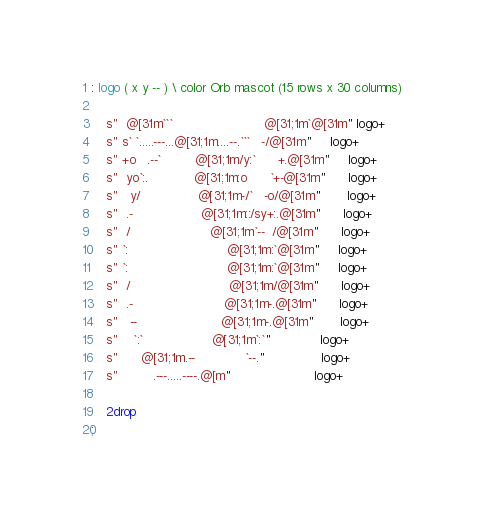Convert code to text. <code><loc_0><loc_0><loc_500><loc_500><_Forth_>
: logo ( x y -- ) \ color Orb mascot (15 rows x 30 columns)

	s"  @[31m```                        @[31;1m`@[31m" logo+
	s" s` `.....---...@[31;1m....--.```   -/@[31m"     logo+
	s" +o   .--`         @[31;1m/y:`      +.@[31m"     logo+
	s"  yo`:.            @[31;1m:o      `+-@[31m"      logo+
	s"   y/               @[31;1m-/`   -o/@[31m"       logo+
	s"  .-                  @[31;1m::/sy+:.@[31m"      logo+
	s"  /                     @[31;1m`--  /@[31m"      logo+
	s" `:                          @[31;1m:`@[31m"     logo+
	s" `:                          @[31;1m:`@[31m"     logo+
	s"  /                          @[31;1m/@[31m"      logo+
	s"  .-                        @[31;1m-.@[31m"      logo+
	s"   --                      @[31;1m-.@[31m"       logo+
	s"    `:`                  @[31;1m`:`"             logo+
	s"      @[31;1m.--             `--."               logo+
	s"         .---.....----.@[m"                      logo+

	2drop
;
</code> 